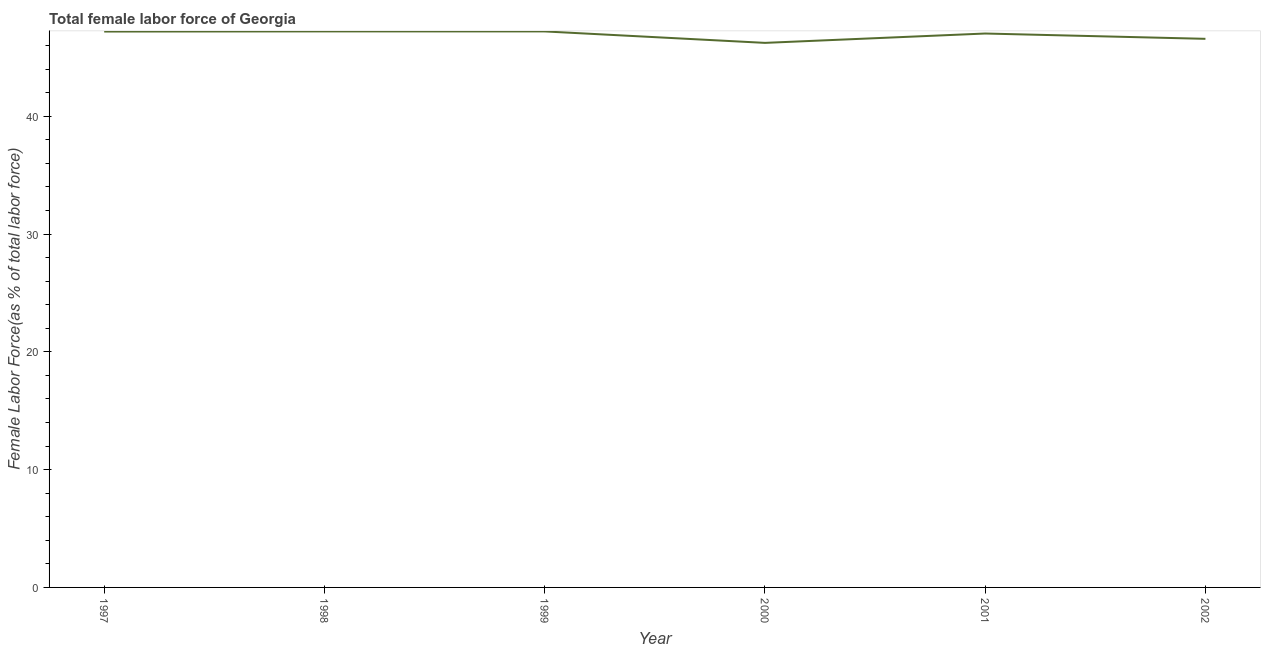What is the total female labor force in 1997?
Your response must be concise. 47.19. Across all years, what is the maximum total female labor force?
Your answer should be very brief. 47.2. Across all years, what is the minimum total female labor force?
Your response must be concise. 46.23. In which year was the total female labor force maximum?
Your response must be concise. 1998. What is the sum of the total female labor force?
Keep it short and to the point. 281.42. What is the difference between the total female labor force in 2000 and 2002?
Your answer should be very brief. -0.34. What is the average total female labor force per year?
Your response must be concise. 46.9. What is the median total female labor force?
Your answer should be very brief. 47.11. Do a majority of the years between 1997 and 2000 (inclusive) have total female labor force greater than 20 %?
Offer a very short reply. Yes. What is the ratio of the total female labor force in 1998 to that in 2001?
Give a very brief answer. 1. Is the total female labor force in 1998 less than that in 1999?
Make the answer very short. No. What is the difference between the highest and the second highest total female labor force?
Your answer should be very brief. 0. Is the sum of the total female labor force in 1998 and 1999 greater than the maximum total female labor force across all years?
Keep it short and to the point. Yes. What is the difference between the highest and the lowest total female labor force?
Your answer should be compact. 0.97. How many lines are there?
Offer a terse response. 1. How many years are there in the graph?
Your answer should be very brief. 6. What is the difference between two consecutive major ticks on the Y-axis?
Your response must be concise. 10. Are the values on the major ticks of Y-axis written in scientific E-notation?
Offer a very short reply. No. Does the graph contain grids?
Keep it short and to the point. No. What is the title of the graph?
Your answer should be compact. Total female labor force of Georgia. What is the label or title of the Y-axis?
Ensure brevity in your answer.  Female Labor Force(as % of total labor force). What is the Female Labor Force(as % of total labor force) in 1997?
Offer a terse response. 47.19. What is the Female Labor Force(as % of total labor force) of 1998?
Give a very brief answer. 47.2. What is the Female Labor Force(as % of total labor force) of 1999?
Ensure brevity in your answer.  47.2. What is the Female Labor Force(as % of total labor force) in 2000?
Give a very brief answer. 46.23. What is the Female Labor Force(as % of total labor force) in 2001?
Provide a short and direct response. 47.02. What is the Female Labor Force(as % of total labor force) of 2002?
Keep it short and to the point. 46.57. What is the difference between the Female Labor Force(as % of total labor force) in 1997 and 1998?
Give a very brief answer. -0.01. What is the difference between the Female Labor Force(as % of total labor force) in 1997 and 1999?
Ensure brevity in your answer.  -0.01. What is the difference between the Female Labor Force(as % of total labor force) in 1997 and 2000?
Offer a very short reply. 0.96. What is the difference between the Female Labor Force(as % of total labor force) in 1997 and 2001?
Provide a short and direct response. 0.17. What is the difference between the Female Labor Force(as % of total labor force) in 1997 and 2002?
Ensure brevity in your answer.  0.62. What is the difference between the Female Labor Force(as % of total labor force) in 1998 and 1999?
Ensure brevity in your answer.  0. What is the difference between the Female Labor Force(as % of total labor force) in 1998 and 2000?
Keep it short and to the point. 0.97. What is the difference between the Female Labor Force(as % of total labor force) in 1998 and 2001?
Your answer should be very brief. 0.18. What is the difference between the Female Labor Force(as % of total labor force) in 1998 and 2002?
Keep it short and to the point. 0.63. What is the difference between the Female Labor Force(as % of total labor force) in 1999 and 2000?
Keep it short and to the point. 0.97. What is the difference between the Female Labor Force(as % of total labor force) in 1999 and 2001?
Offer a terse response. 0.18. What is the difference between the Female Labor Force(as % of total labor force) in 1999 and 2002?
Your answer should be very brief. 0.63. What is the difference between the Female Labor Force(as % of total labor force) in 2000 and 2001?
Make the answer very short. -0.79. What is the difference between the Female Labor Force(as % of total labor force) in 2000 and 2002?
Give a very brief answer. -0.34. What is the difference between the Female Labor Force(as % of total labor force) in 2001 and 2002?
Offer a terse response. 0.45. What is the ratio of the Female Labor Force(as % of total labor force) in 1997 to that in 1998?
Give a very brief answer. 1. What is the ratio of the Female Labor Force(as % of total labor force) in 1997 to that in 1999?
Your response must be concise. 1. What is the ratio of the Female Labor Force(as % of total labor force) in 1997 to that in 2001?
Make the answer very short. 1. What is the ratio of the Female Labor Force(as % of total labor force) in 1998 to that in 2000?
Your answer should be compact. 1.02. What is the ratio of the Female Labor Force(as % of total labor force) in 1998 to that in 2002?
Keep it short and to the point. 1.01. What is the ratio of the Female Labor Force(as % of total labor force) in 1999 to that in 2001?
Your answer should be very brief. 1. What is the ratio of the Female Labor Force(as % of total labor force) in 2000 to that in 2001?
Ensure brevity in your answer.  0.98. What is the ratio of the Female Labor Force(as % of total labor force) in 2000 to that in 2002?
Make the answer very short. 0.99. 